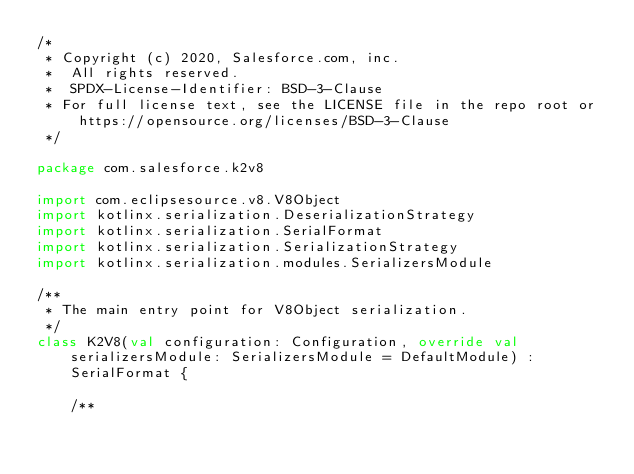Convert code to text. <code><loc_0><loc_0><loc_500><loc_500><_Kotlin_>/*
 * Copyright (c) 2020, Salesforce.com, inc.
 *  All rights reserved.
 *  SPDX-License-Identifier: BSD-3-Clause
 * For full license text, see the LICENSE file in the repo root or https://opensource.org/licenses/BSD-3-Clause
 */

package com.salesforce.k2v8

import com.eclipsesource.v8.V8Object
import kotlinx.serialization.DeserializationStrategy
import kotlinx.serialization.SerialFormat
import kotlinx.serialization.SerializationStrategy
import kotlinx.serialization.modules.SerializersModule

/**
 * The main entry point for V8Object serialization.
 */
class K2V8(val configuration: Configuration, override val serializersModule: SerializersModule = DefaultModule) :
    SerialFormat {

    /**</code> 